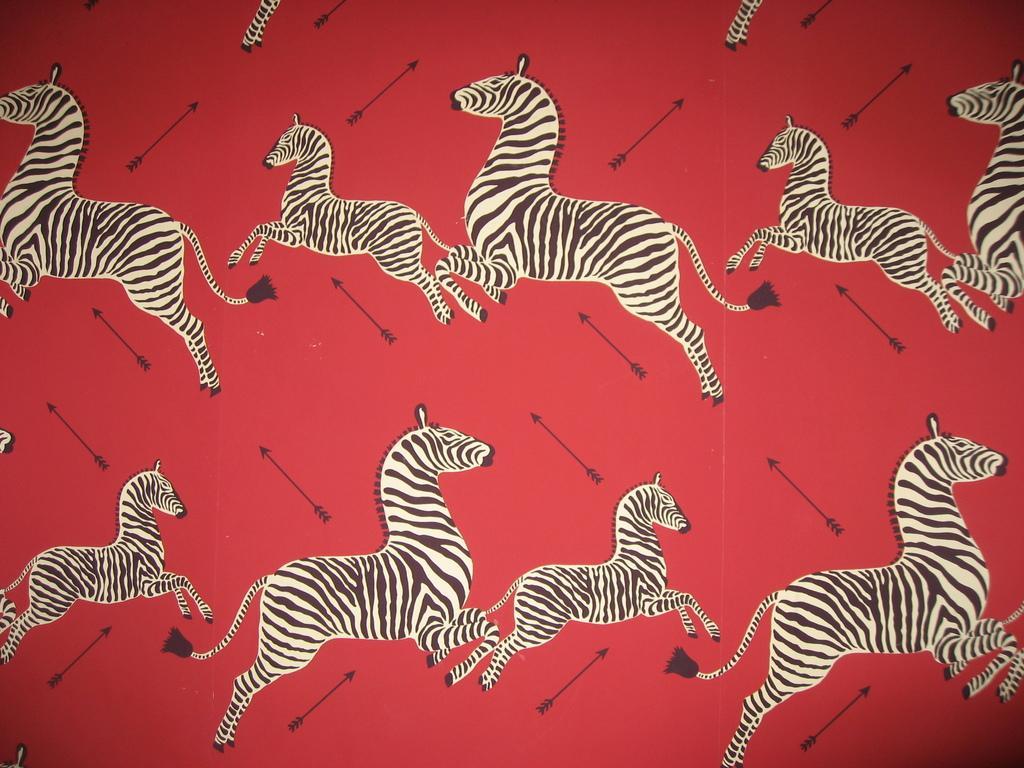How would you summarize this image in a sentence or two? In this picture we can see zebras and objects on the red surface. 